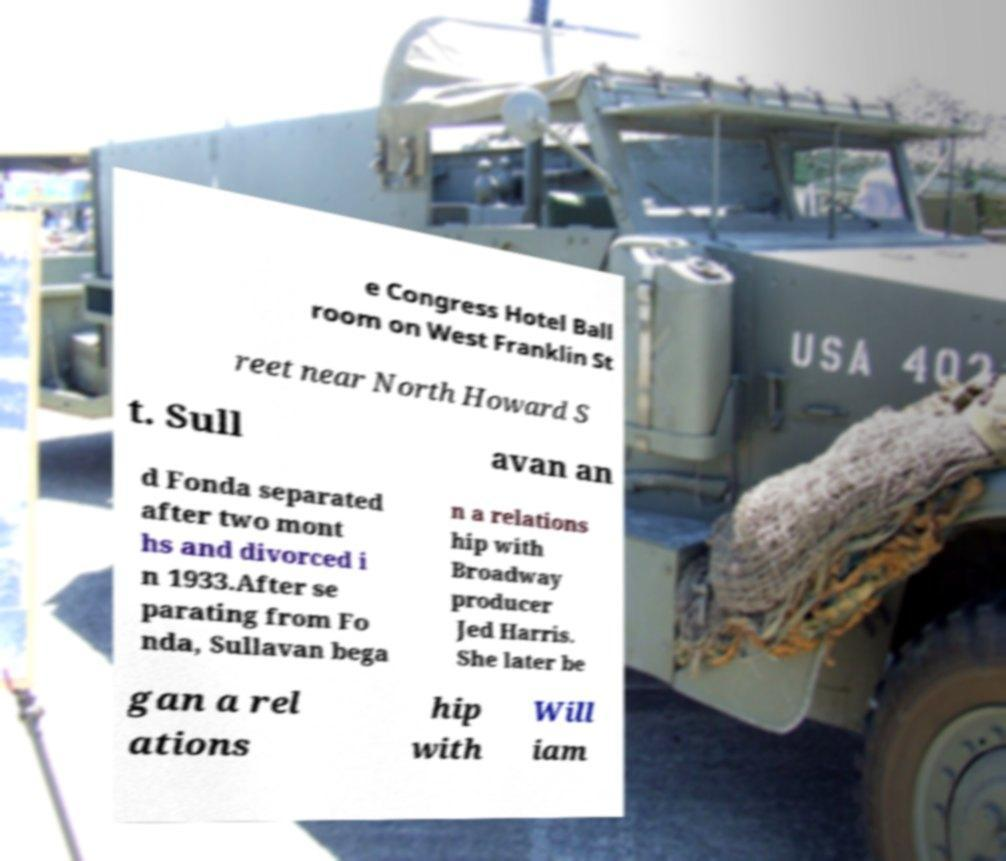Can you accurately transcribe the text from the provided image for me? e Congress Hotel Ball room on West Franklin St reet near North Howard S t. Sull avan an d Fonda separated after two mont hs and divorced i n 1933.After se parating from Fo nda, Sullavan bega n a relations hip with Broadway producer Jed Harris. She later be gan a rel ations hip with Will iam 